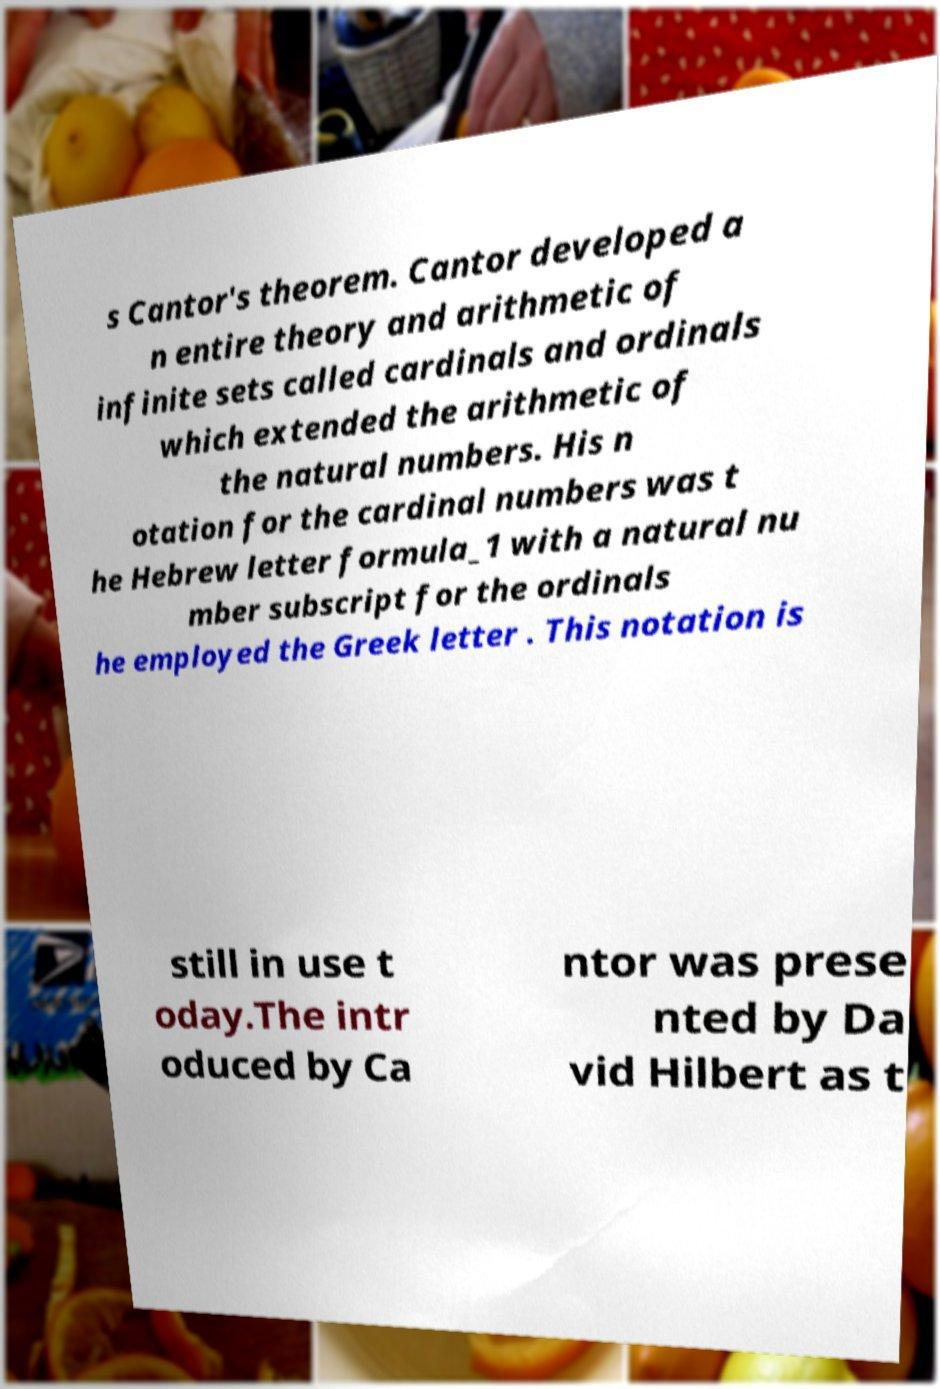Please identify and transcribe the text found in this image. s Cantor's theorem. Cantor developed a n entire theory and arithmetic of infinite sets called cardinals and ordinals which extended the arithmetic of the natural numbers. His n otation for the cardinal numbers was t he Hebrew letter formula_1 with a natural nu mber subscript for the ordinals he employed the Greek letter . This notation is still in use t oday.The intr oduced by Ca ntor was prese nted by Da vid Hilbert as t 